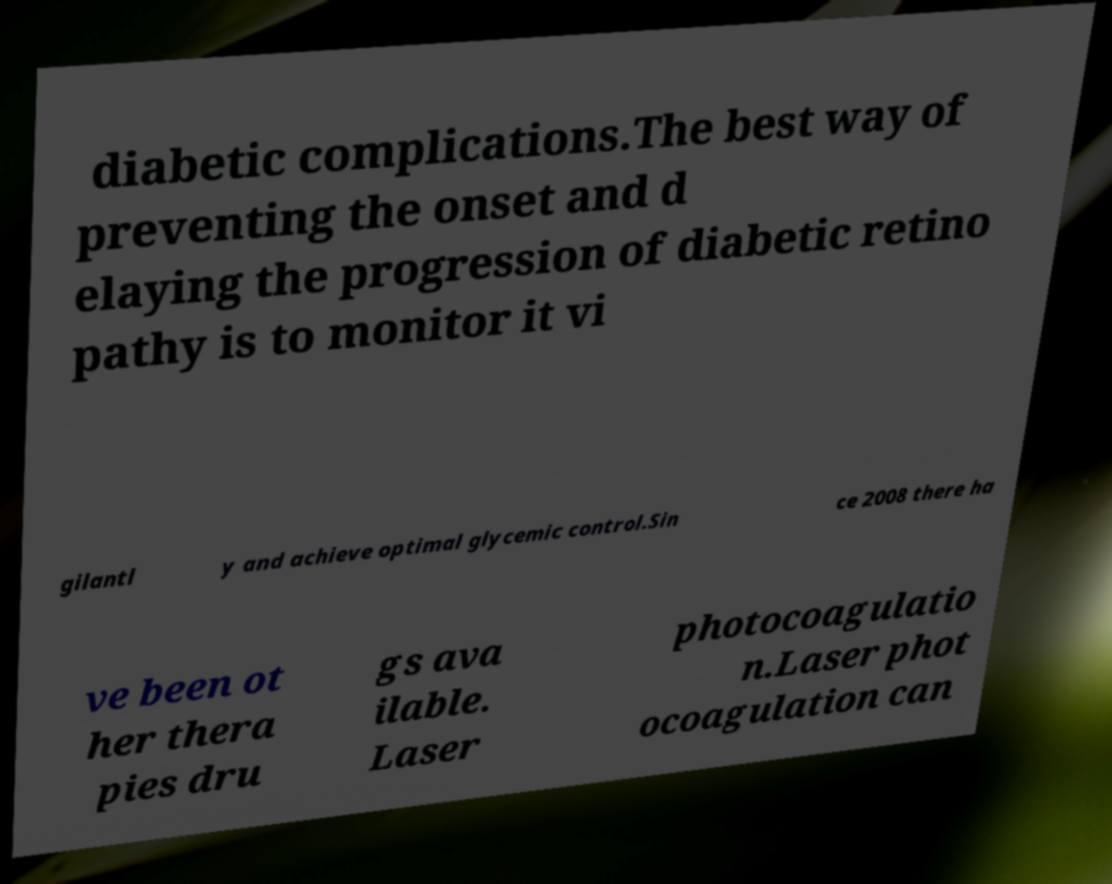Can you accurately transcribe the text from the provided image for me? diabetic complications.The best way of preventing the onset and d elaying the progression of diabetic retino pathy is to monitor it vi gilantl y and achieve optimal glycemic control.Sin ce 2008 there ha ve been ot her thera pies dru gs ava ilable. Laser photocoagulatio n.Laser phot ocoagulation can 